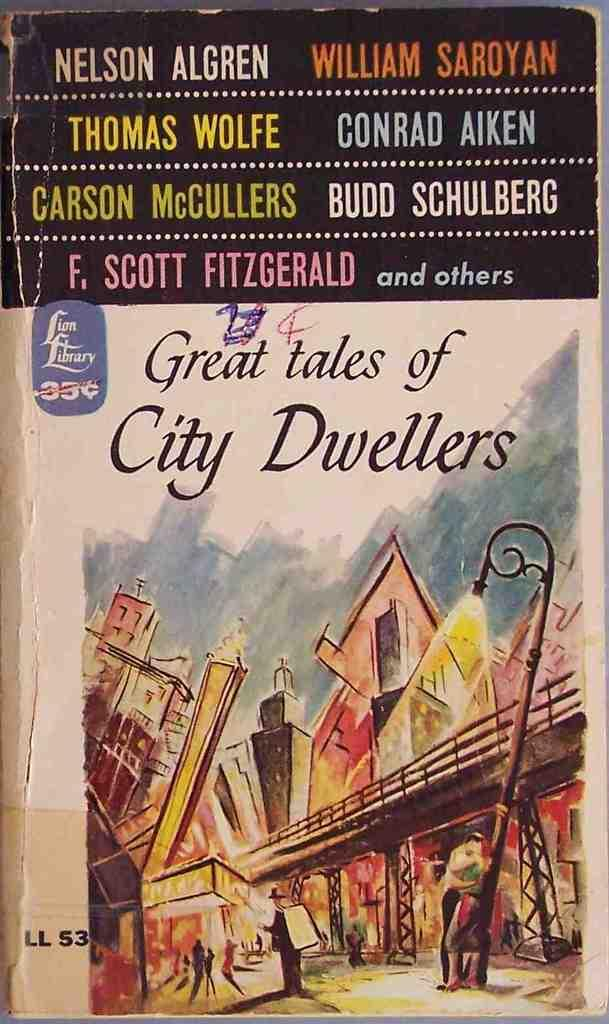<image>
Present a compact description of the photo's key features. The book titled Great tales of City Dwellers by an assortment of authors. 